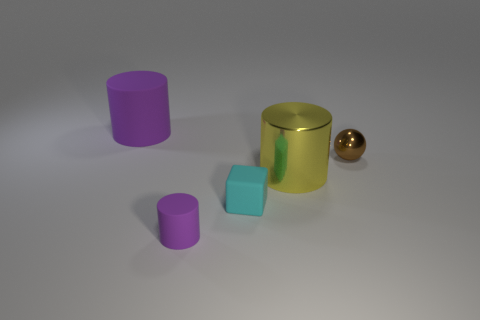Add 4 tiny purple matte things. How many objects exist? 9 Subtract all cylinders. How many objects are left? 2 Subtract 0 green spheres. How many objects are left? 5 Subtract all large rubber cylinders. Subtract all shiny balls. How many objects are left? 3 Add 1 tiny purple things. How many tiny purple things are left? 2 Add 3 tiny metal balls. How many tiny metal balls exist? 4 